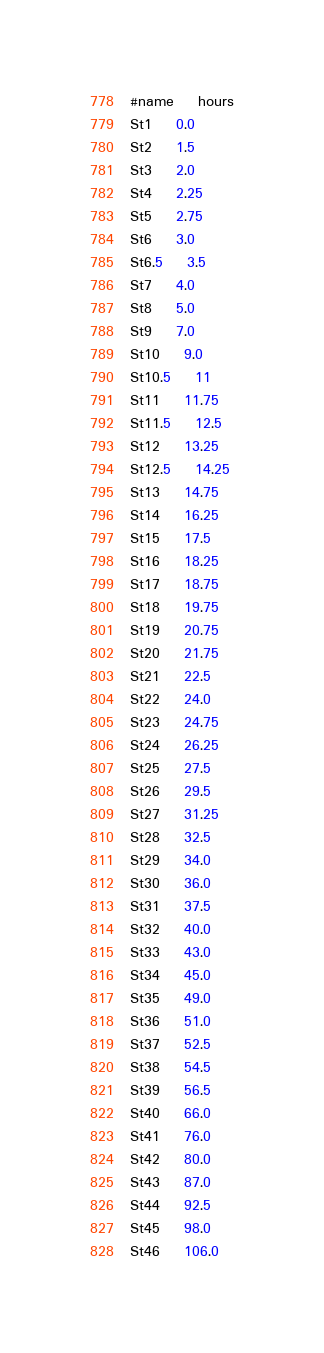<code> <loc_0><loc_0><loc_500><loc_500><_SQL_>#name	hours
St1	0.0
St2	1.5
St3	2.0
St4	2.25
St5	2.75
St6	3.0
St6.5	3.5
St7	4.0
St8	5.0
St9	7.0
St10	9.0
St10.5	11
St11	11.75
St11.5	12.5
St12	13.25
St12.5	14.25
St13	14.75
St14	16.25
St15	17.5
St16	18.25
St17	18.75
St18	19.75
St19	20.75
St20	21.75
St21	22.5
St22	24.0
St23	24.75
St24	26.25
St25	27.5
St26	29.5
St27	31.25
St28	32.5
St29	34.0
St30	36.0
St31	37.5
St32	40.0
St33	43.0
St34	45.0
St35	49.0
St36	51.0
St37	52.5
St38	54.5
St39	56.5
St40	66.0
St41	76.0
St42	80.0
St43	87.0
St44	92.5
St45	98.0
St46	106.0
</code> 